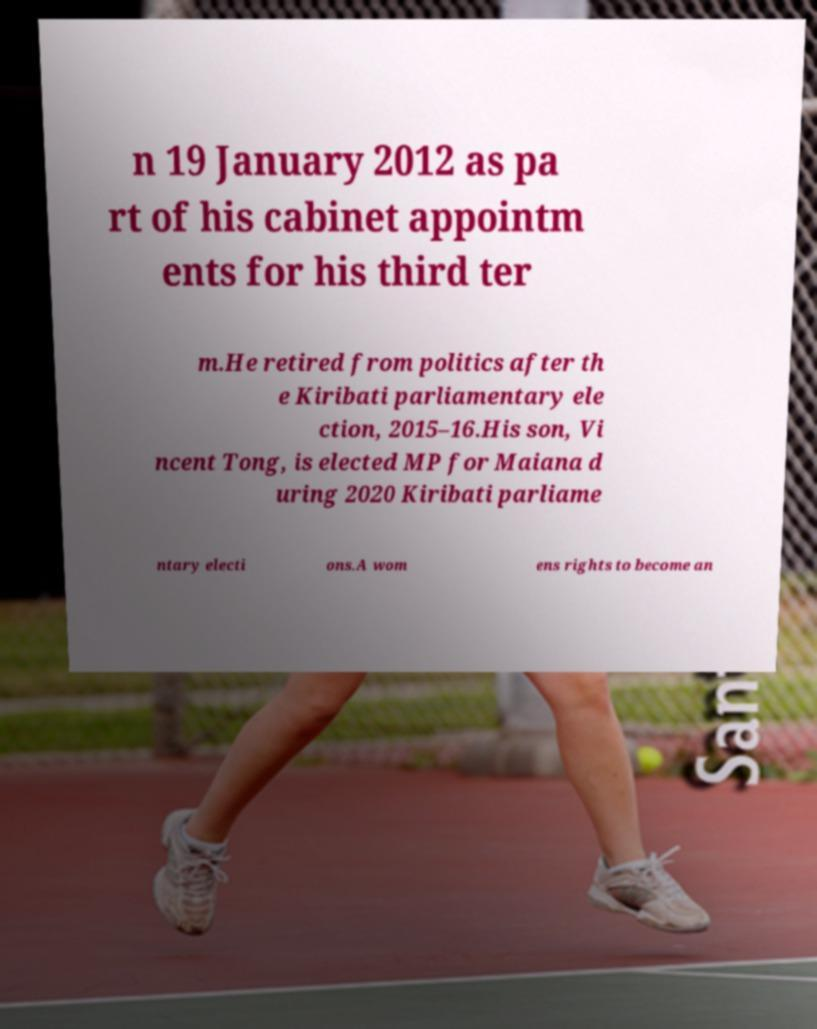There's text embedded in this image that I need extracted. Can you transcribe it verbatim? n 19 January 2012 as pa rt of his cabinet appointm ents for his third ter m.He retired from politics after th e Kiribati parliamentary ele ction, 2015–16.His son, Vi ncent Tong, is elected MP for Maiana d uring 2020 Kiribati parliame ntary electi ons.A wom ens rights to become an 